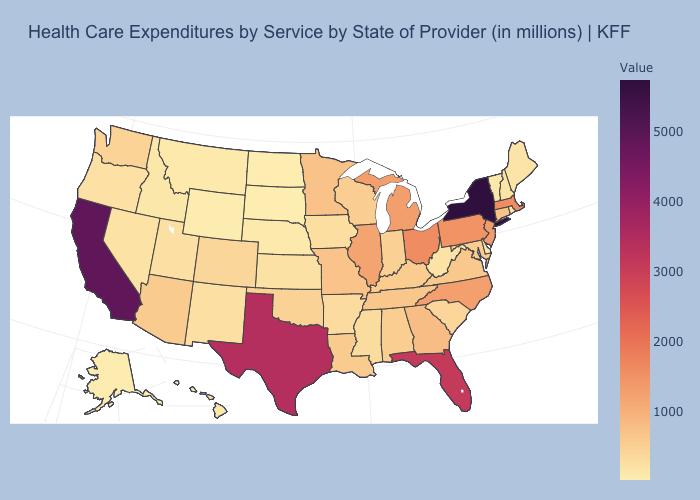Does Ohio have the highest value in the MidWest?
Be succinct. Yes. Does New York have the highest value in the USA?
Be succinct. Yes. Does New Hampshire have a lower value than Texas?
Short answer required. Yes. Is the legend a continuous bar?
Be succinct. Yes. Does New York have the highest value in the USA?
Quick response, please. Yes. Does Mississippi have the highest value in the South?
Keep it brief. No. Which states hav the highest value in the MidWest?
Be succinct. Ohio. 